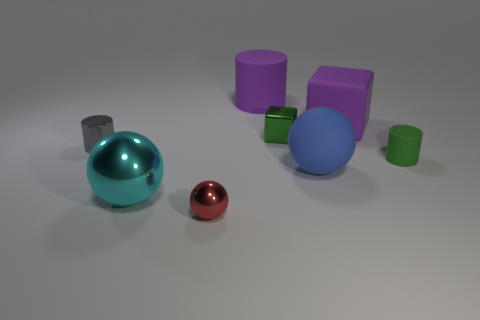Add 2 blue rubber things. How many objects exist? 10 Subtract 1 spheres. How many spheres are left? 2 Subtract all purple rubber cylinders. How many cylinders are left? 2 Subtract all cubes. How many objects are left? 6 Subtract 1 gray cylinders. How many objects are left? 7 Subtract all blue objects. Subtract all big purple rubber cubes. How many objects are left? 6 Add 1 big blocks. How many big blocks are left? 2 Add 1 rubber cylinders. How many rubber cylinders exist? 3 